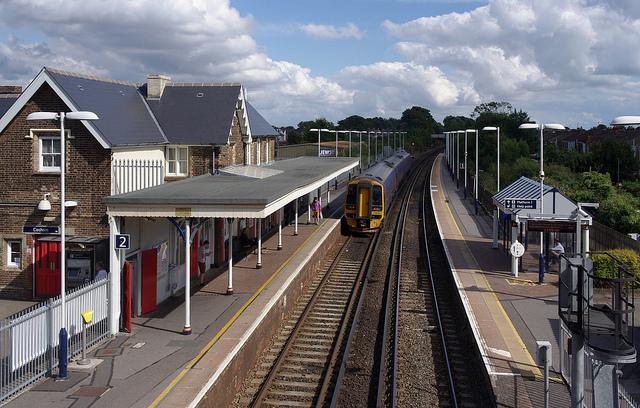Is this picture from another era?
Be succinct. No. What color is the building?
Answer briefly. Brown. Is this a train station?
Give a very brief answer. Yes. How many sets of train tracks are next to these buildings?
Quick response, please. 2. What number is on the platform on the left?
Be succinct. 2. 